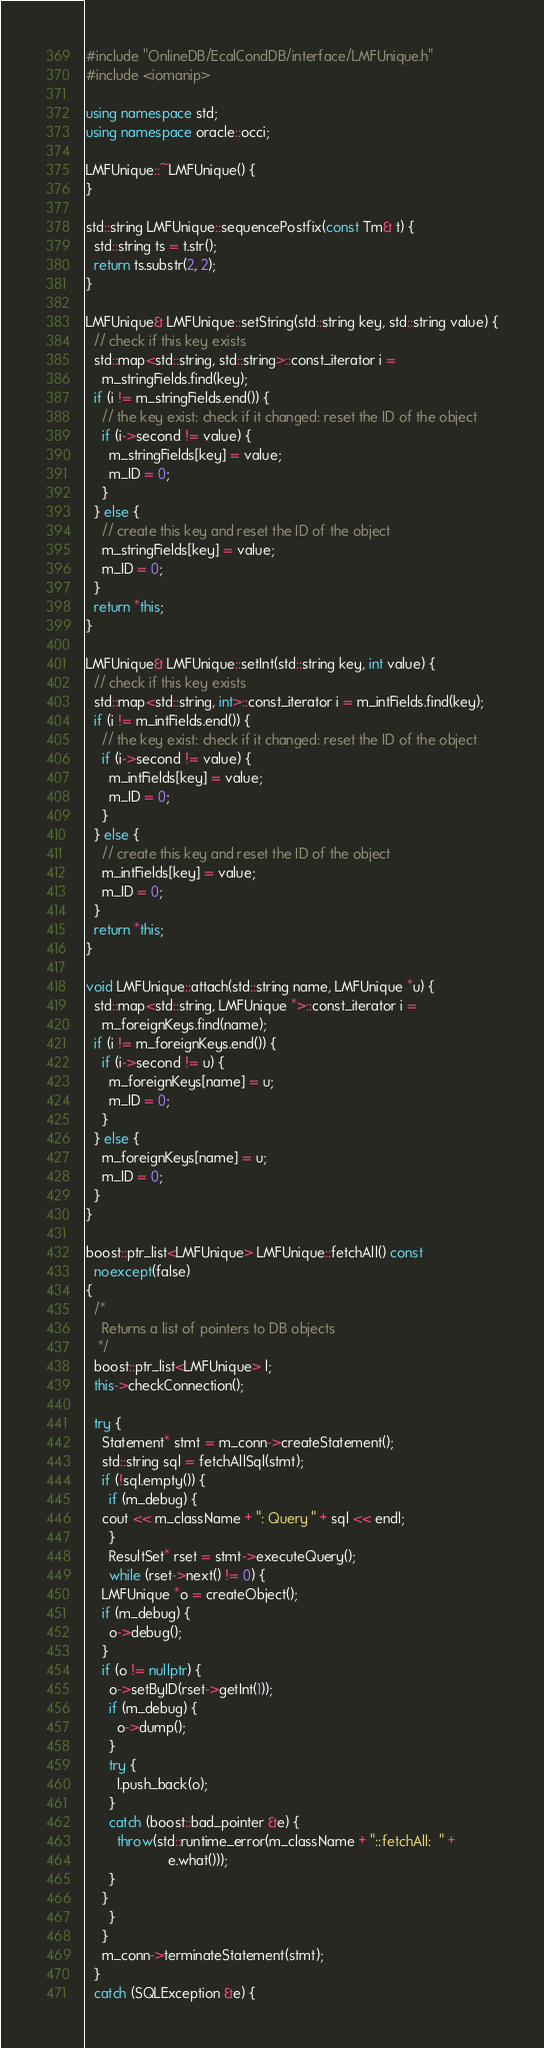Convert code to text. <code><loc_0><loc_0><loc_500><loc_500><_C++_>#include "OnlineDB/EcalCondDB/interface/LMFUnique.h"
#include <iomanip>

using namespace std;
using namespace oracle::occi;

LMFUnique::~LMFUnique() {
}

std::string LMFUnique::sequencePostfix(const Tm& t) {
  std::string ts = t.str();
  return ts.substr(2, 2);
}

LMFUnique& LMFUnique::setString(std::string key, std::string value) {
  // check if this key exists
  std::map<std::string, std::string>::const_iterator i = 
    m_stringFields.find(key);
  if (i != m_stringFields.end()) {
    // the key exist: check if it changed: reset the ID of the object
    if (i->second != value) {
      m_stringFields[key] = value;
      m_ID = 0;
    }
  } else {
    // create this key and reset the ID of the object
    m_stringFields[key] = value;
    m_ID = 0;    
  }
  return *this;
}

LMFUnique& LMFUnique::setInt(std::string key, int value) {
  // check if this key exists
  std::map<std::string, int>::const_iterator i = m_intFields.find(key);
  if (i != m_intFields.end()) {
    // the key exist: check if it changed: reset the ID of the object
    if (i->second != value) {
      m_intFields[key] = value;
      m_ID = 0;
    }
  } else {
    // create this key and reset the ID of the object
    m_intFields[key] = value;
    m_ID = 0;    
  }
  return *this;
}

void LMFUnique::attach(std::string name, LMFUnique *u) {
  std::map<std::string, LMFUnique *>::const_iterator i = 
    m_foreignKeys.find(name);
  if (i != m_foreignKeys.end()) {
    if (i->second != u) {
      m_foreignKeys[name] = u;
      m_ID = 0;
    }
  } else {
    m_foreignKeys[name] = u;
    m_ID = 0;
  }
}

boost::ptr_list<LMFUnique> LMFUnique::fetchAll() const  
  noexcept(false)
{
  /*
    Returns a list of pointers to DB objects
   */
  boost::ptr_list<LMFUnique> l;
  this->checkConnection();

  try {
    Statement* stmt = m_conn->createStatement();
    std::string sql = fetchAllSql(stmt);
    if (!sql.empty()) {
      if (m_debug) {
	cout << m_className + ": Query " + sql << endl;
      }
      ResultSet* rset = stmt->executeQuery();
      while (rset->next() != 0) {
	LMFUnique *o = createObject();
	if (m_debug) {
	  o->debug();
	}
	if (o != nullptr) {
	  o->setByID(rset->getInt(1));
	  if (m_debug) {
	    o->dump();
	  }
	  try {
	    l.push_back(o);
	  }
	  catch (boost::bad_pointer &e) {
	    throw(std::runtime_error(m_className + "::fetchAll:  " + 
				     e.what()));
	  }
	}
      }
    }
    m_conn->terminateStatement(stmt);
  }
  catch (SQLException &e) {</code> 